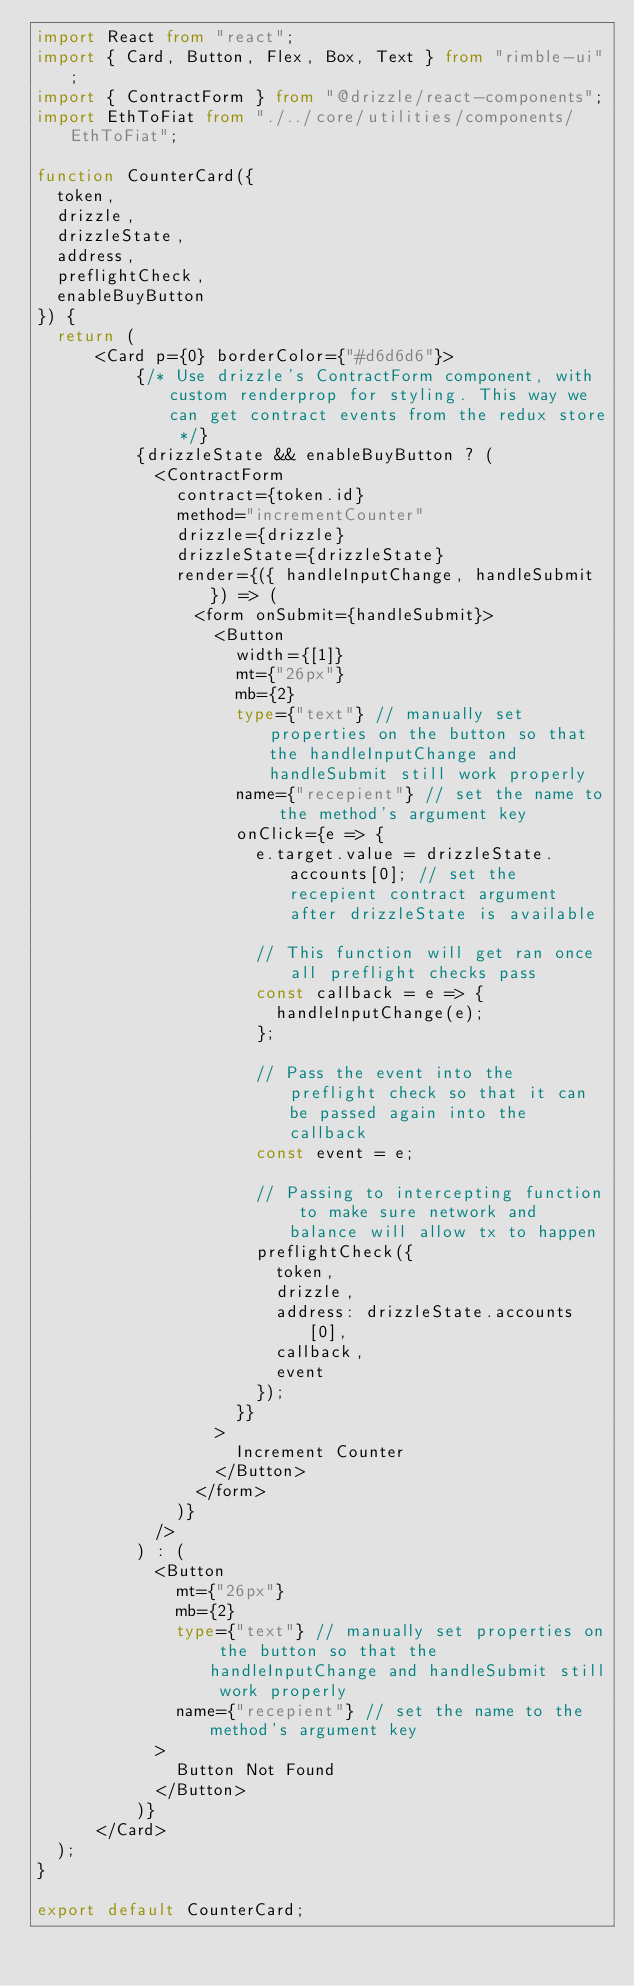Convert code to text. <code><loc_0><loc_0><loc_500><loc_500><_TypeScript_>import React from "react";
import { Card, Button, Flex, Box, Text } from "rimble-ui";
import { ContractForm } from "@drizzle/react-components";
import EthToFiat from "./../core/utilities/components/EthToFiat";

function CounterCard({
  token,
  drizzle,
  drizzleState,
  address,
  preflightCheck,
  enableBuyButton
}) {
  return (
      <Card p={0} borderColor={"#d6d6d6"}>
          {/* Use drizzle's ContractForm component, with custom renderprop for styling. This way we can get contract events from the redux store */}
          {drizzleState && enableBuyButton ? (
            <ContractForm
              contract={token.id}
              method="incrementCounter"
              drizzle={drizzle}
              drizzleState={drizzleState}
              render={({ handleInputChange, handleSubmit }) => (
                <form onSubmit={handleSubmit}>
                  <Button
                    width={[1]}
                    mt={"26px"}
                    mb={2}
                    type={"text"} // manually set properties on the button so that the handleInputChange and handleSubmit still work properly
                    name={"recepient"} // set the name to the method's argument key
                    onClick={e => {
                      e.target.value = drizzleState.accounts[0]; // set the recepient contract argument after drizzleState is available

                      // This function will get ran once all preflight checks pass
                      const callback = e => {
                        handleInputChange(e);
                      };

                      // Pass the event into the preflight check so that it can be passed again into the callback
                      const event = e;

                      // Passing to intercepting function to make sure network and balance will allow tx to happen
                      preflightCheck({
                        token,
                        drizzle,
                        address: drizzleState.accounts[0],
                        callback,
                        event
                      });
                    }}
                  >
                    Increment Counter
                  </Button>
                </form>
              )}
            />
          ) : (
            <Button
              mt={"26px"}
              mb={2}
              type={"text"} // manually set properties on the button so that the handleInputChange and handleSubmit still work properly
              name={"recepient"} // set the name to the method's argument key
            >
              Button Not Found
            </Button>
          )}
      </Card>
  );
}

export default CounterCard;</code> 